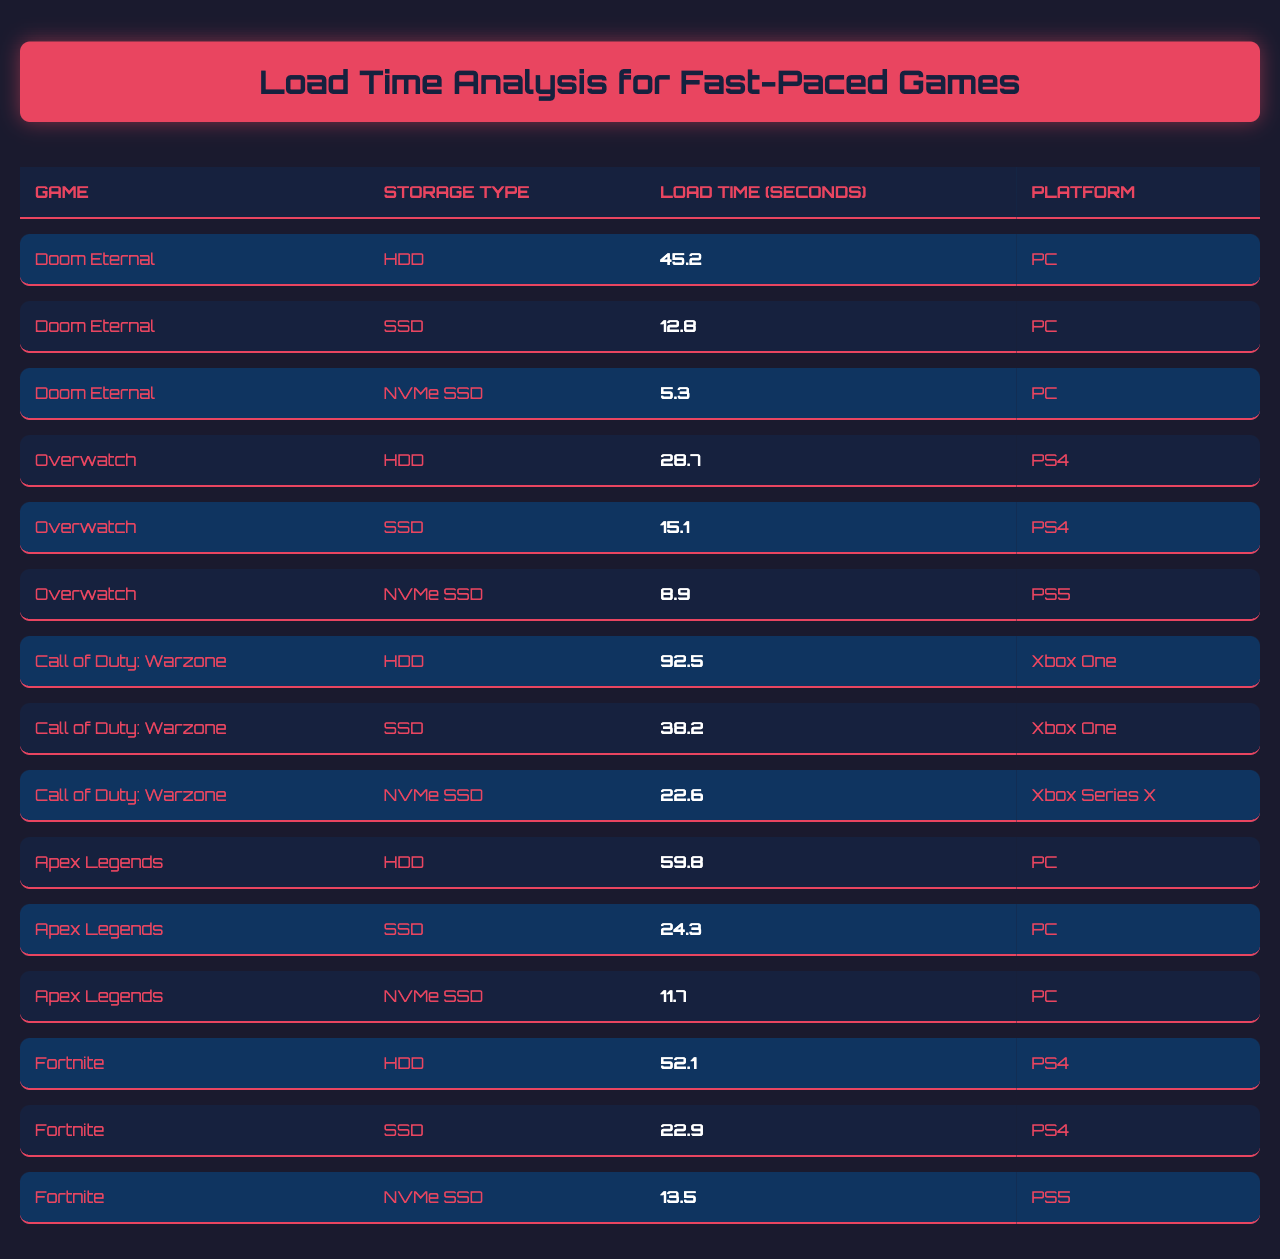What is the load time for "Doom Eternal" on an NVMe SSD? The table lists "Doom Eternal" with an NVMe SSD, showing a load time of 5.3 seconds.
Answer: 5.3 seconds What is the storage type with the fastest load time for "Apex Legends"? Looking at the load times for "Apex Legends," the fastest is with an NVMe SSD, which is 11.7 seconds.
Answer: NVMe SSD Is the load time for "Fortnite" on SSD less than that on HDD? The load time for "Fortnite" on SSD is 22.9 seconds, and on HDD, it is 52.1 seconds. Since 22.9 is less than 52.1, the statement is true.
Answer: Yes Which game has the longest load time on HDD? Checking the HDD load times, "Call of Duty: Warzone" has the longest load time at 92.5 seconds.
Answer: Call of Duty: Warzone If we compare load times for "Overwatch" across platforms, which one shows the greatest difference between HDD and NVMe SSD? The load time for "Overwatch" on HDD (28.7 seconds) and on NVMe SSD for PS5 (8.9 seconds) shows a difference of 28.7 - 8.9 = 19.8 seconds.
Answer: 19.8 seconds What is the average load time for "Doom Eternal" across all storage types? Adding the load times: 45.2 + 12.8 + 5.3 = 63.3 seconds. There are 3 storage types, so average = 63.3 / 3 = 21.1 seconds.
Answer: 21.1 seconds For "Call of Duty: Warzone," does using an NVMe SSD provide a significant reduction in load time compared to HDD? The load times are 92.5 seconds on HDD and 22.6 seconds on NVMe SSD, a reduction of 92.5 - 22.6 = 69.9 seconds, which is significant.
Answer: Yes Which platform shows the lowest load time for "Fortnite"? The table indicates that "Fortnite" has a load time of 13.5 seconds on NVMe SSD for PS5, which is lower than other listed platforms.
Answer: PS5 (NVMe SSD) How much faster is the load time for "Apex Legends" on SSD compared to HDD? The load time for "Apex Legends" on SSD is 24.3 seconds, and on HDD, it is 59.8 seconds. The difference is 59.8 - 24.3 = 35.5 seconds, indicating it's significantly faster.
Answer: 35.5 seconds What is the minimum load time recorded for any game across all storage types? By reviewing all load times, the minimum is 5.3 seconds for "Doom Eternal" on NVMe SSD.
Answer: 5.3 seconds 